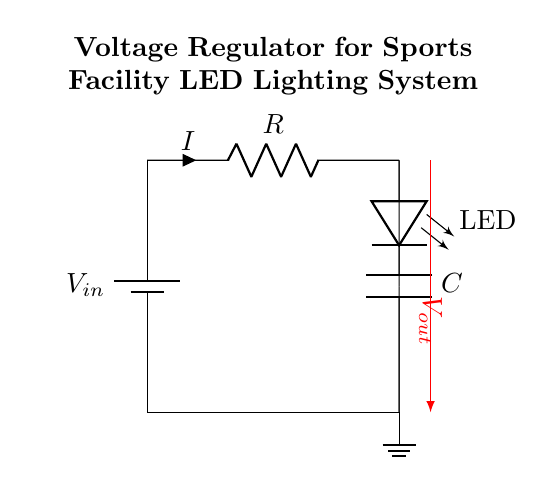What is the input voltage of the circuit? The input voltage is labeled as V in on the battery symbol at the left side of the circuit, which indicates the voltage supplied to the circuit.
Answer: V in What type of load is connected in this circuit? The load is represented by the element labeled as LED, indicating that the circuit is designed to power a light-emitting diode as the load.
Answer: LED What is the function of the capacitor in this circuit? The capacitor is connected in parallel to the load (LED) and provides stability to the voltage by smoothing out fluctuations, ensuring consistent operation of the LED.
Answer: Smoothing What is the output voltage of the circuit? The output voltage is indicated by V out on the right side of the circuit, which reflects the voltage delivered to the load (LED).
Answer: V out What is the role of the resistor in this circuit? The resistor is placed in series with the input voltage V in and the capacitor, and it limits the current flowing into the capacitor and LED, helping to control circuit behavior.
Answer: Current limiting What is the correlation between resistance and current in this circuit? According to Ohm's law, the current flowing through the circuit is inversely proportional to the resistance of the resistor, meaning higher resistance results in lower current flow.
Answer: Inverse How does the capacitor affect the voltage regulation in this circuit? The capacitor stores and releases charge, helping to maintain a steady voltage level at the output (V out) despite variations in input (V in) or load conditions, assisting in voltage regulation.
Answer: Voltage stabilization 